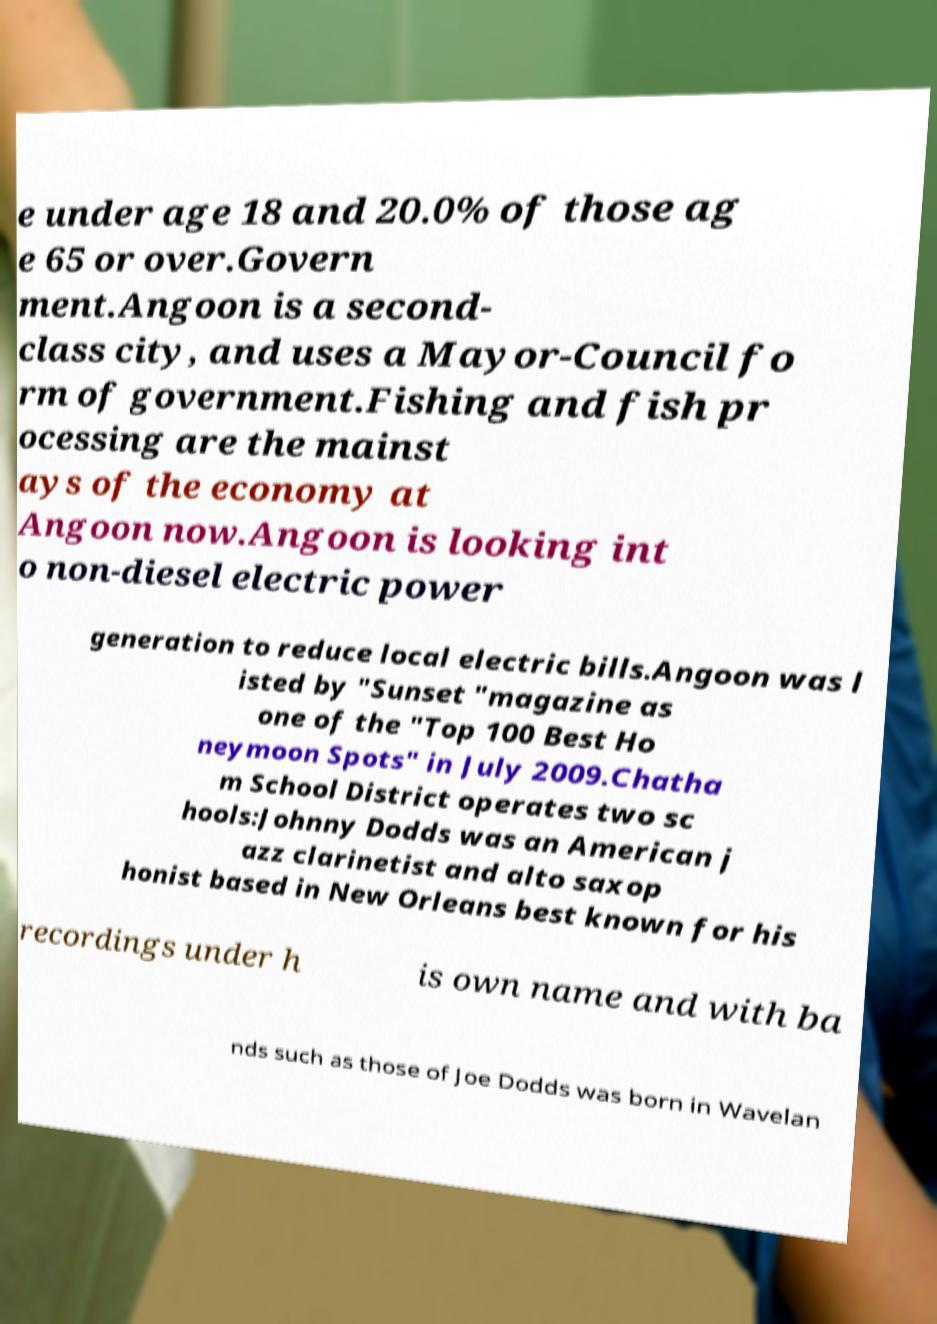There's text embedded in this image that I need extracted. Can you transcribe it verbatim? e under age 18 and 20.0% of those ag e 65 or over.Govern ment.Angoon is a second- class city, and uses a Mayor-Council fo rm of government.Fishing and fish pr ocessing are the mainst ays of the economy at Angoon now.Angoon is looking int o non-diesel electric power generation to reduce local electric bills.Angoon was l isted by "Sunset "magazine as one of the "Top 100 Best Ho neymoon Spots" in July 2009.Chatha m School District operates two sc hools:Johnny Dodds was an American j azz clarinetist and alto saxop honist based in New Orleans best known for his recordings under h is own name and with ba nds such as those of Joe Dodds was born in Wavelan 